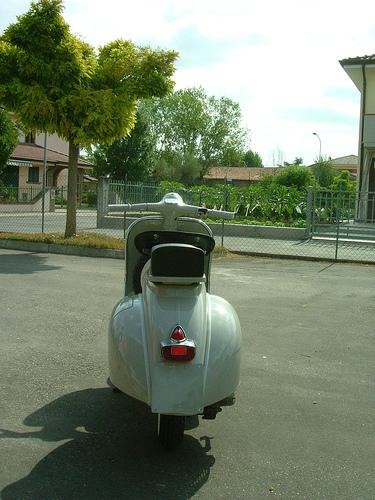How many unicorns are there in the image? 0 